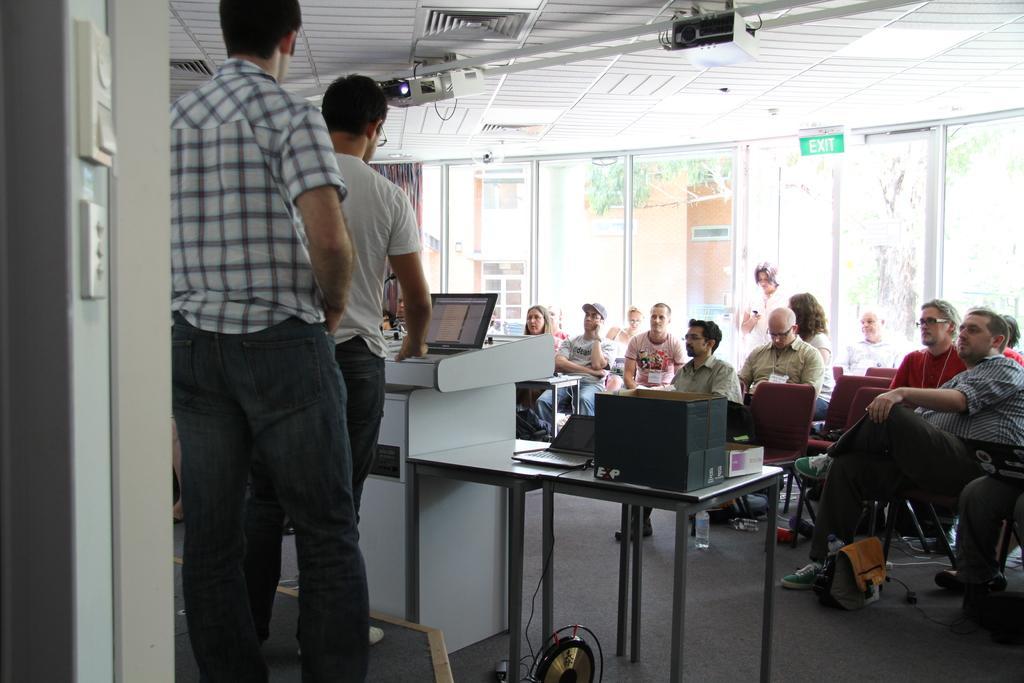Can you describe this image briefly? In this picture there are two men standing and other people setting does a laptop. In the background this is a glass door, building and some trees. 